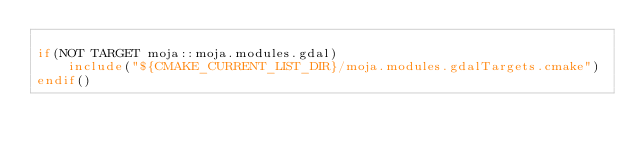<code> <loc_0><loc_0><loc_500><loc_500><_CMake_>
if(NOT TARGET moja::moja.modules.gdal)
	include("${CMAKE_CURRENT_LIST_DIR}/moja.modules.gdalTargets.cmake")
endif()</code> 